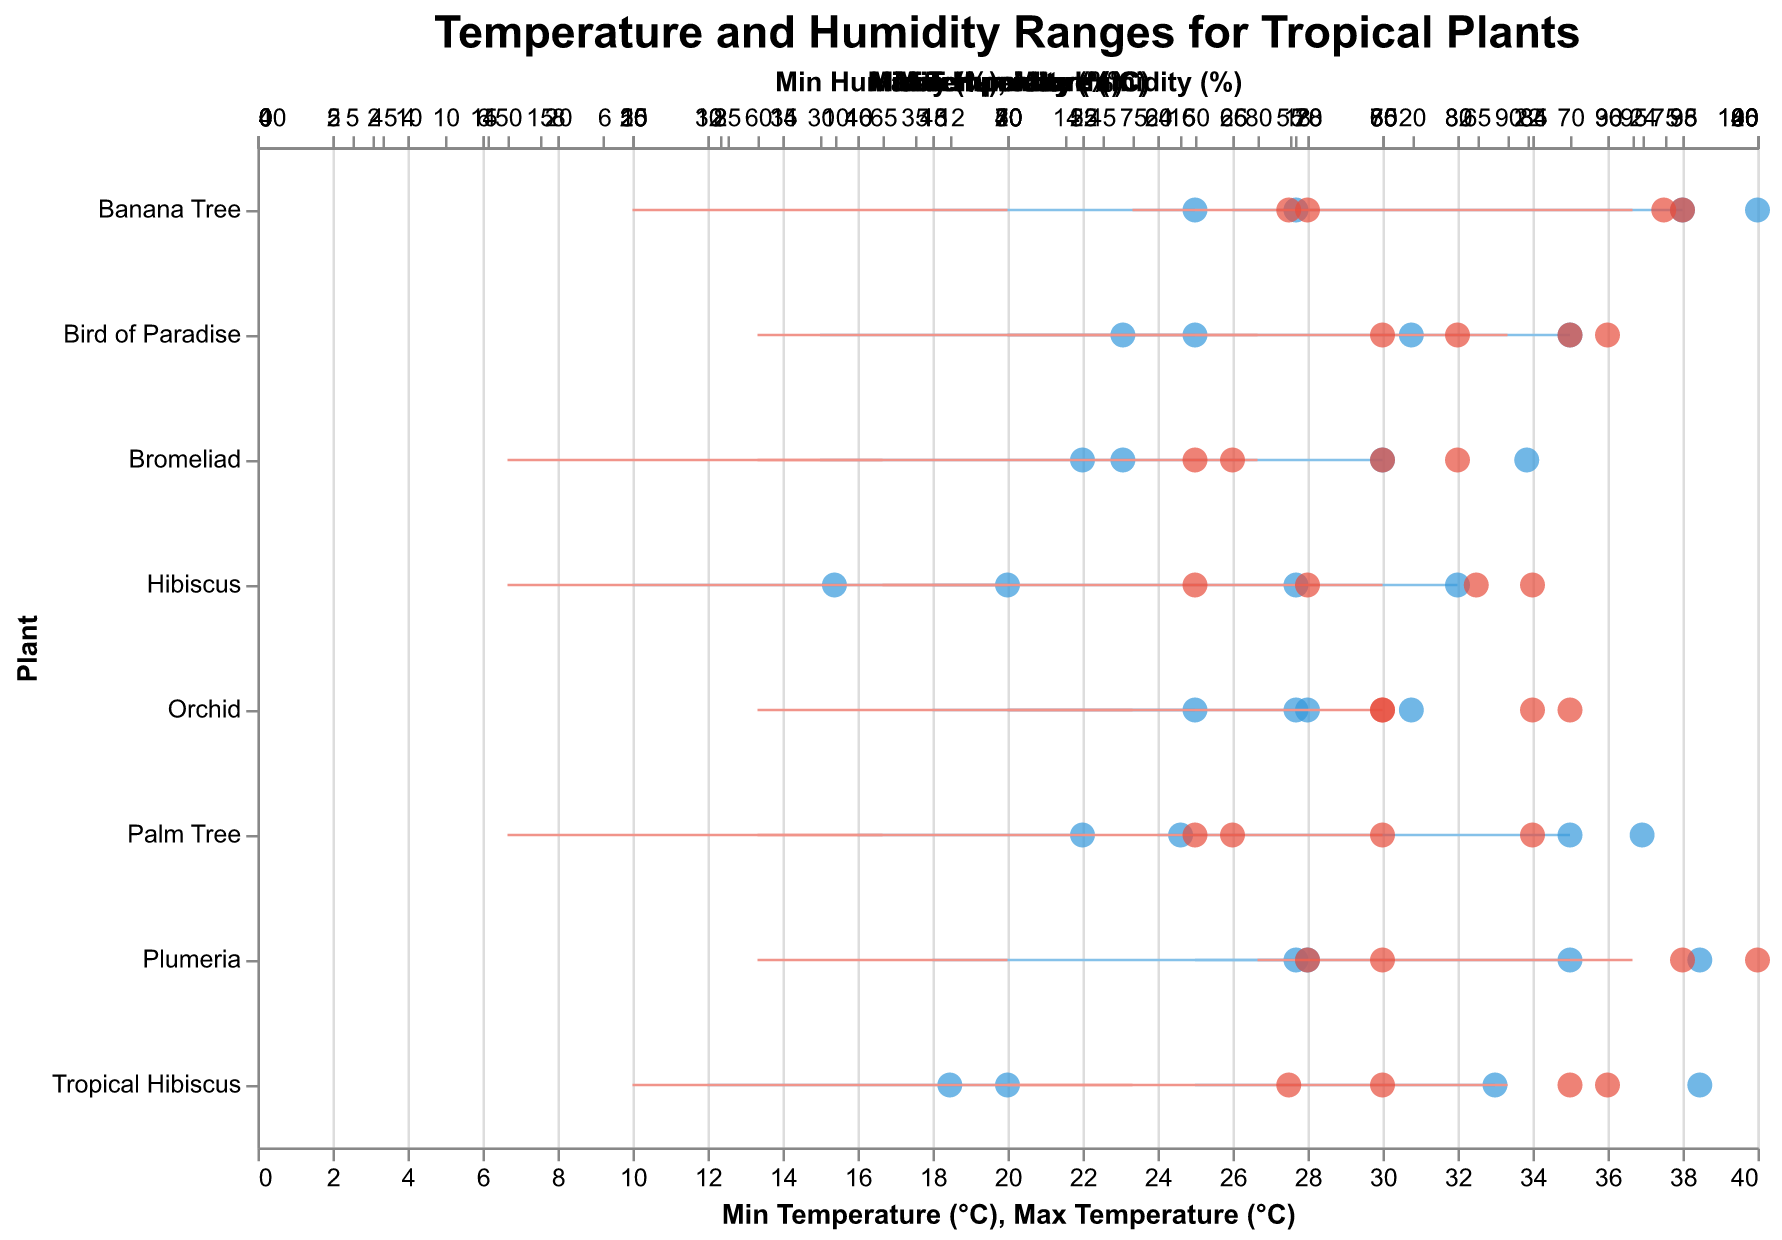What's the title of the figure? The title is located at the top center of the figure and it uses a bold, size 18 font.
Answer: Temperature and Humidity Ranges for Tropical Plants Which plant has the highest maximum temperature range during summer? To find this, check the data points corresponding to summer for all plants and identify the one with the highest maximum temperature. The Banana Tree has a maximum summer temperature of 38°C.
Answer: Banana Tree What is the difference in maximum temperature ranges between the Bird of Paradise in summer and winter? First, locate the maximum temperature for the Bird of Paradise in summer (35°C) and in winter (25°C). The difference is calculated as 35°C - 25°C = 10°C.
Answer: 10°C Which season has a higher average minimum humidity for Hibiscus? Check the minimum humidity values for Hibiscus in summer (65%) and winter (50%). Summer has a higher minimum humidity.
Answer: Summer How does the minimum temperature for Palm Tree in winter compare to its maximum temperature in winter? Look at the minimum (16°C) and maximum (22°C) temperatures for Palm Tree in winter. The minimum temperature is less than the maximum temperature.
Answer: Less than What are the combined temperature ranges (min to max) for Plumeria across both seasons? For summer, Plumeria ranges from 25°C to 35°C and for winter, from 18°C to 28°C. Combine these ranges to get one range from the lowest minimum to the highest maximum, i.e., 18°C to 35°C.
Answer: 18°C to 35°C Which plant requires the highest maximum humidity in summer? Inspect summer data for all plants and identify the one with the highest maximum humidity. The Plumeria and the Banana Tree both have a maximum summer humidity of 95%.
Answer: Plumeria and Banana Tree What is the average minimum temperature across all plants for winter? Sum the minimum temperatures for winter (15+10+15+18+18+18+16+12) and divide by the number of plants (8). The sum is 122, so the average is 122/8 = 15.25°C.
Answer: 15.25°C Which plant has the narrowest humidity range in winter? Check the humidity ranges for all plants in winter and find the smallest range by subtracting the minimum from the maximum humidity. Bromeliad has the narrowest humidity range from 50% to 65%, which gives a range of 15%.
Answer: Bromeliad 